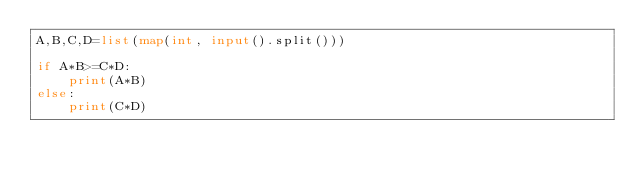Convert code to text. <code><loc_0><loc_0><loc_500><loc_500><_Python_>A,B,C,D=list(map(int, input().split()))

if A*B>=C*D:
    print(A*B)
else:
    print(C*D)</code> 